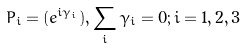Convert formula to latex. <formula><loc_0><loc_0><loc_500><loc_500>P _ { i } = ( e ^ { i \gamma _ { i } } ) , \sum _ { i } \gamma _ { i } = 0 ; i = 1 , 2 , 3</formula> 